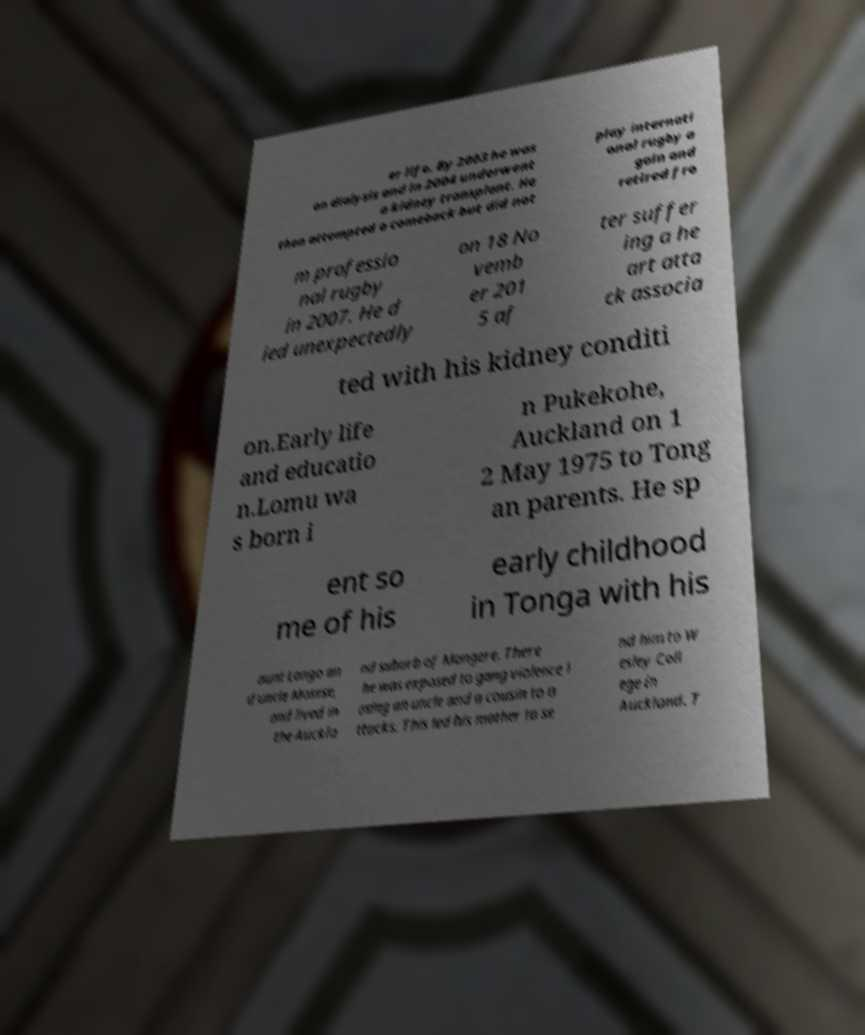Can you accurately transcribe the text from the provided image for me? er life. By 2003 he was on dialysis and in 2004 underwent a kidney transplant. He then attempted a comeback but did not play internati onal rugby a gain and retired fro m professio nal rugby in 2007. He d ied unexpectedly on 18 No vemb er 201 5 af ter suffer ing a he art atta ck associa ted with his kidney conditi on.Early life and educatio n.Lomu wa s born i n Pukekohe, Auckland on 1 2 May 1975 to Tong an parents. He sp ent so me of his early childhood in Tonga with his aunt Longo an d uncle Mosese, and lived in the Auckla nd suburb of Mangere. There he was exposed to gang violence l osing an uncle and a cousin to a ttacks. This led his mother to se nd him to W esley Coll ege in Auckland. T 